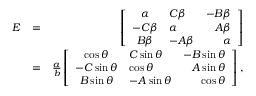<formula> <loc_0><loc_0><loc_500><loc_500>\begin{array} { r l r } { E } & { = } & { \left [ \begin{array} { c l r r } { \alpha } & { C \beta } & { - B \beta } \\ { - C \beta } & { \alpha } & { A \beta } \\ { B \beta } & { - A \beta } & { \alpha } \end{array} \right ] } \\ & { = } & { \frac { a } { b } \left [ \begin{array} { c l r r } { \cos \theta } & { C \sin \theta } & { - B \sin \theta } \\ { - C \sin \theta } & { \cos \theta } & { A \sin \theta } \\ { B \sin \theta } & { - A \sin \theta } & { \cos \theta } \end{array} \right ] , } \end{array}</formula> 